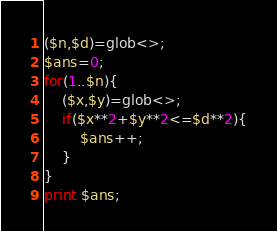Convert code to text. <code><loc_0><loc_0><loc_500><loc_500><_Perl_>($n,$d)=glob<>;
$ans=0;
for(1..$n){
	($x,$y)=glob<>;
	if($x**2+$y**2<=$d**2){
		$ans++;
	}
}
print $ans;</code> 